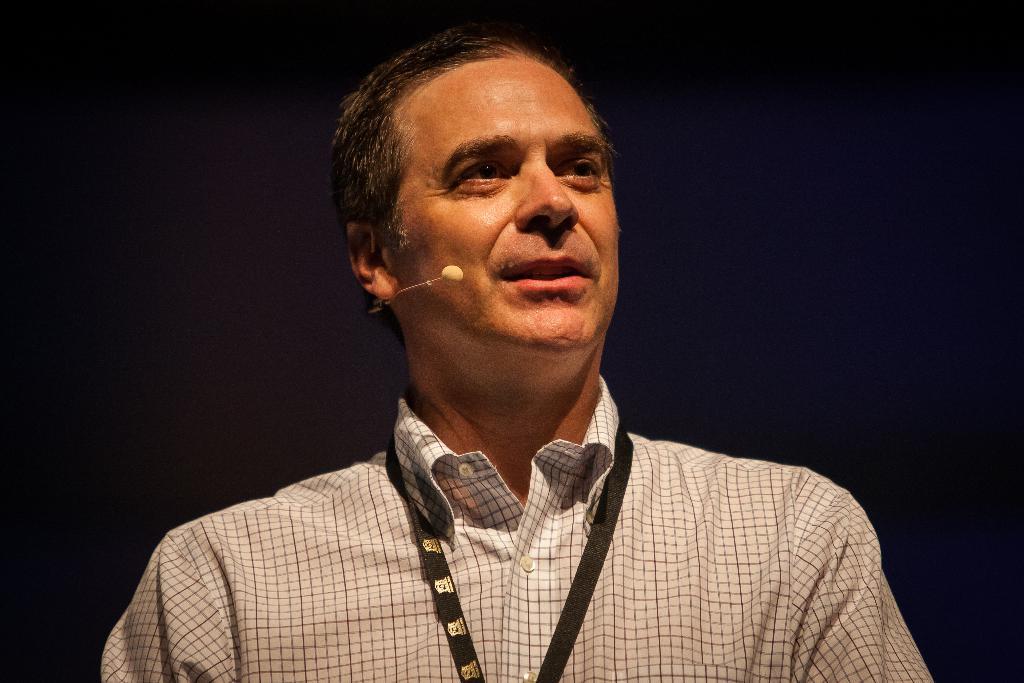Describe this image in one or two sentences. In this image there is a man. There is a mike. The person wearing checked shirt and an ID card. There is a black background. 